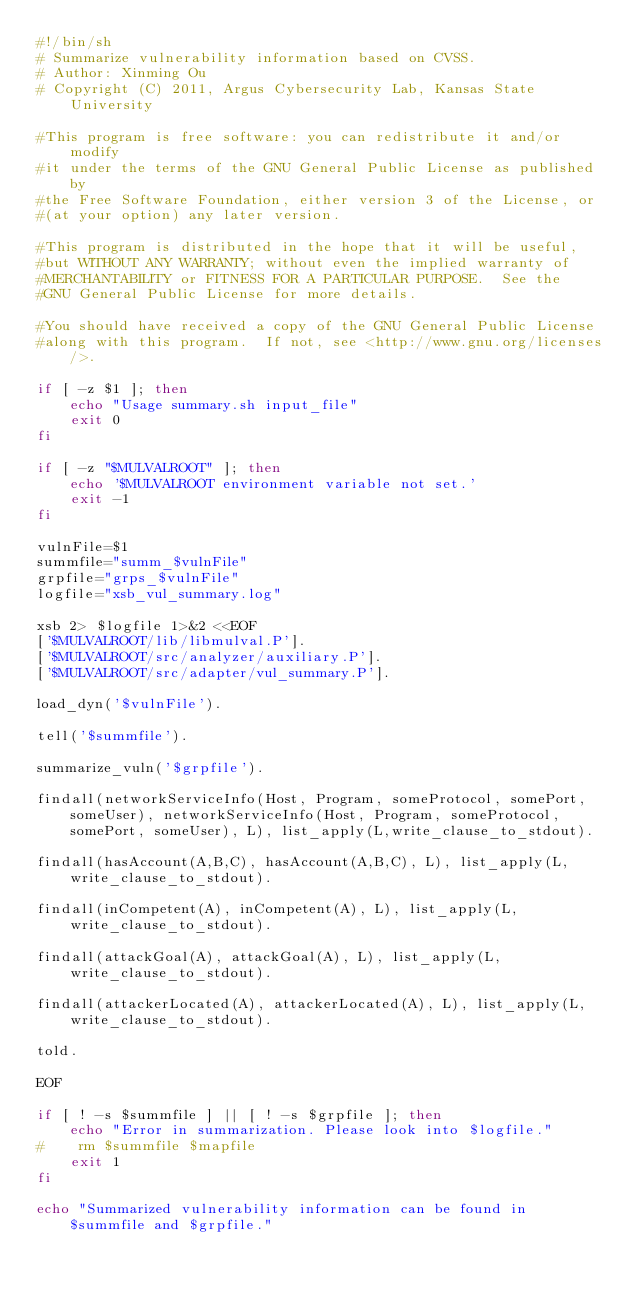<code> <loc_0><loc_0><loc_500><loc_500><_Bash_>#!/bin/sh
# Summarize vulnerability information based on CVSS.
# Author: Xinming Ou
# Copyright (C) 2011, Argus Cybersecurity Lab, Kansas State University

#This program is free software: you can redistribute it and/or modify
#it under the terms of the GNU General Public License as published by
#the Free Software Foundation, either version 3 of the License, or
#(at your option) any later version.

#This program is distributed in the hope that it will be useful,
#but WITHOUT ANY WARRANTY; without even the implied warranty of
#MERCHANTABILITY or FITNESS FOR A PARTICULAR PURPOSE.  See the
#GNU General Public License for more details.

#You should have received a copy of the GNU General Public License
#along with this program.  If not, see <http://www.gnu.org/licenses/>.

if [ -z $1 ]; then
    echo "Usage summary.sh input_file"
    exit 0
fi

if [ -z "$MULVALROOT" ]; then
    echo '$MULVALROOT environment variable not set.'
    exit -1
fi

vulnFile=$1
summfile="summ_$vulnFile"
grpfile="grps_$vulnFile"
logfile="xsb_vul_summary.log"

xsb 2> $logfile 1>&2 <<EOF
['$MULVALROOT/lib/libmulval.P'].
['$MULVALROOT/src/analyzer/auxiliary.P'].
['$MULVALROOT/src/adapter/vul_summary.P'].

load_dyn('$vulnFile').

tell('$summfile').

summarize_vuln('$grpfile').

findall(networkServiceInfo(Host, Program, someProtocol, somePort, someUser), networkServiceInfo(Host, Program, someProtocol, somePort, someUser), L), list_apply(L,write_clause_to_stdout).

findall(hasAccount(A,B,C), hasAccount(A,B,C), L), list_apply(L,write_clause_to_stdout).

findall(inCompetent(A), inCompetent(A), L), list_apply(L,write_clause_to_stdout).

findall(attackGoal(A), attackGoal(A), L), list_apply(L,write_clause_to_stdout).

findall(attackerLocated(A), attackerLocated(A), L), list_apply(L,write_clause_to_stdout).

told.

EOF

if [ ! -s $summfile ] || [ ! -s $grpfile ]; then
    echo "Error in summarization. Please look into $logfile."
#    rm $summfile $mapfile
    exit 1
fi

echo "Summarized vulnerability information can be found in $summfile and $grpfile."</code> 